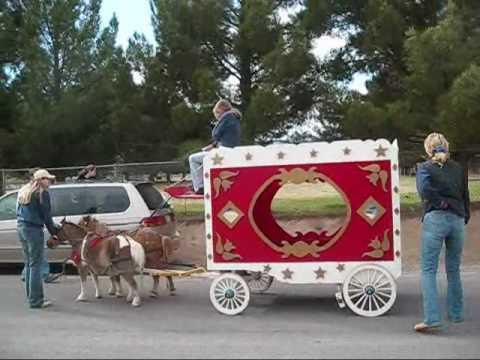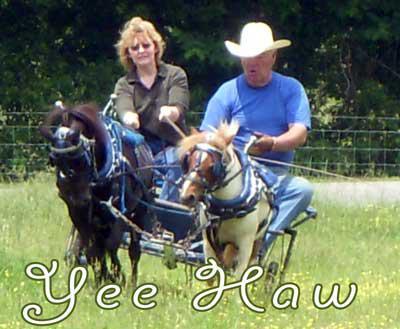The first image is the image on the left, the second image is the image on the right. Examine the images to the left and right. Is the description "One image shows a child in blue jeans without a hat holding out at least one arm while riding a two-wheeled cart pulled across dirt by a pony." accurate? Answer yes or no. No. The first image is the image on the left, the second image is the image on the right. For the images displayed, is the sentence "there is at least one pony pulling a cart, there is a man in a blue tshirt and a cowboy hat sitting" factually correct? Answer yes or no. Yes. 